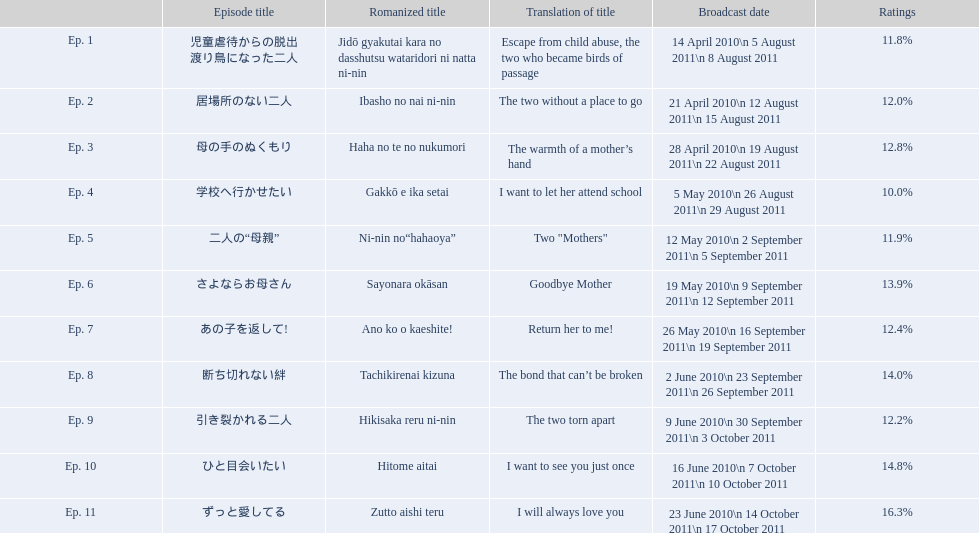What was the name of the first episode of this show? 児童虐待からの脱出 渡り鳥になった二人. 